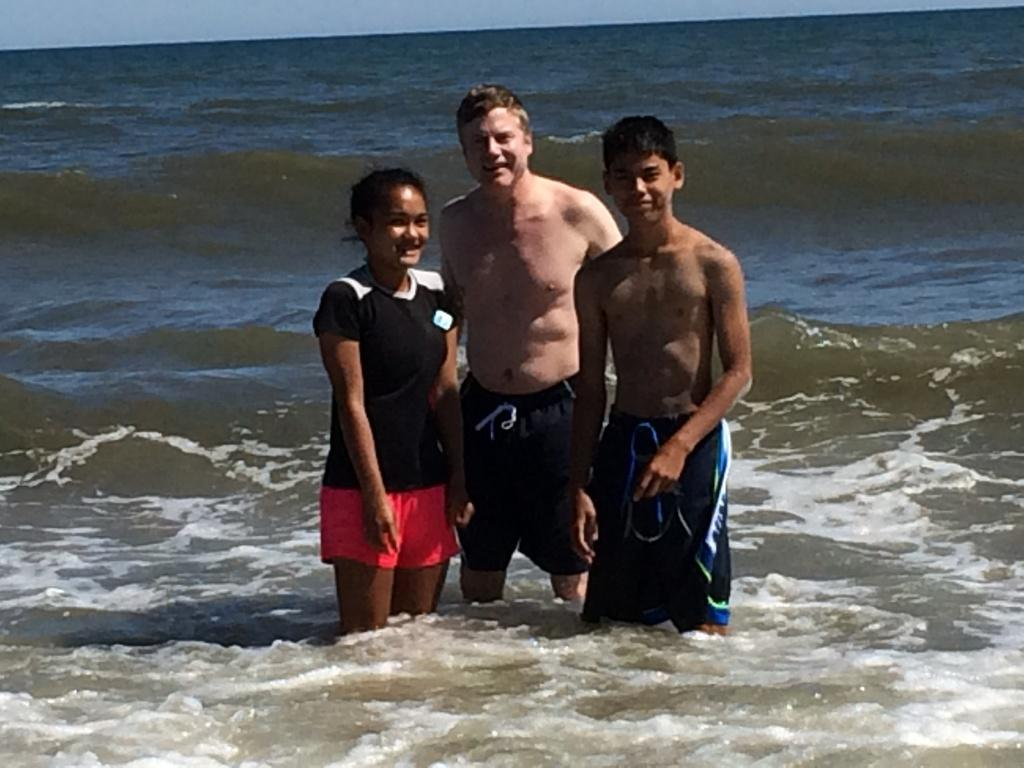How many people are in the image? There are three persons in the image. What are the persons doing in the image? The persons are standing in the water. What is the facial expression of the persons in the image? The persons are smiling. What is visible at the top of the image? The sky is visible at the top of the image. What type of chin can be seen on the person in the middle of the image? There is no chin visible on the person in the middle of the image, as the image only shows the persons from the shoulders up. --- Facts: 1. There is a car in the image. 2. The car is red. 3. The car has four wheels. 4. There is a road in the image. 5. The road is paved. Absurd Topics: bird, ocean, dance Conversation: What is the main subject of the image? The main subject of the image is a car. What color is the car? The car is red. How many wheels does the car have? The car has four wheels. What is the surface of the road in the image? The road is paved. Reasoning: Let's think step by step in order to produce the conversation. We start by identifying the main subject in the image, which is the car. Then, we describe the car's color and the number of wheels it has. Finally, we mention the road's surface to give a sense of the setting. Absurd Question/Answer: Can you see any birds flying over the ocean in the image? There is no ocean or birds present in the image; it features a red car on a paved road. 